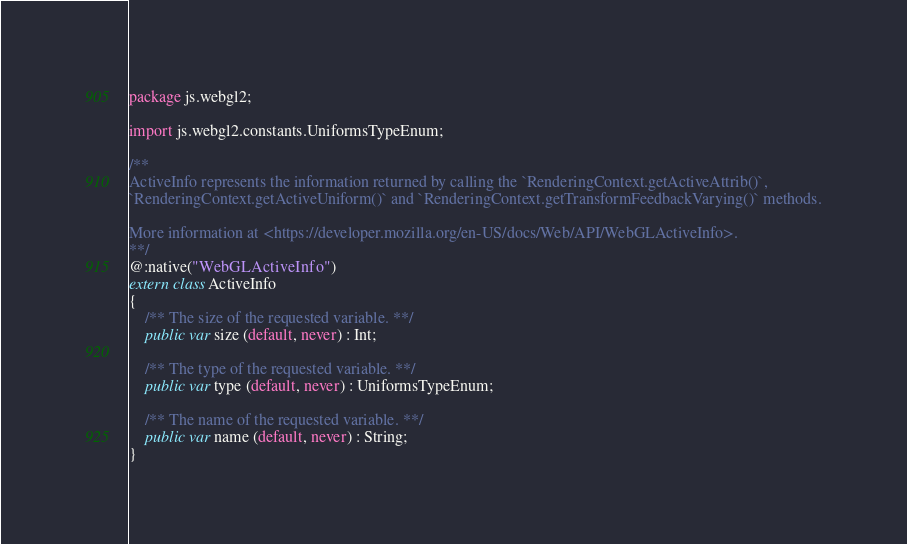<code> <loc_0><loc_0><loc_500><loc_500><_Haxe_>package js.webgl2;

import js.webgl2.constants.UniformsTypeEnum;

/**
ActiveInfo represents the information returned by calling the `RenderingContext.getActiveAttrib()`,
`RenderingContext.getActiveUniform()` and `RenderingContext.getTransformFeedbackVarying()` methods.

More information at <https://developer.mozilla.org/en-US/docs/Web/API/WebGLActiveInfo>.
**/
@:native("WebGLActiveInfo")
extern class ActiveInfo
{
	/** The size of the requested variable. **/
	public var size (default, never) : Int;

	/** The type of the requested variable. **/
	public var type (default, never) : UniformsTypeEnum;

	/** The name of the requested variable. **/
	public var name (default, never) : String;
}
</code> 